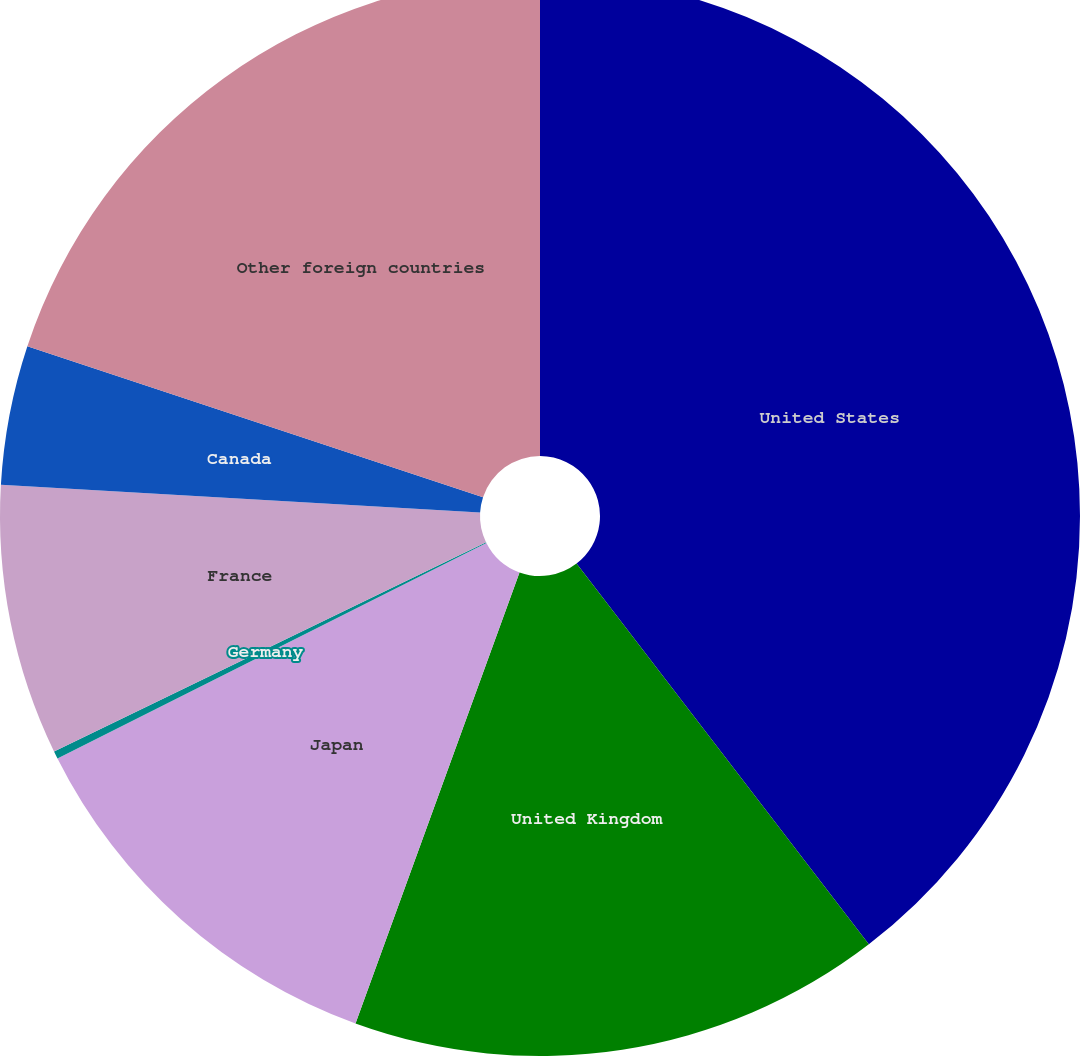Convert chart to OTSL. <chart><loc_0><loc_0><loc_500><loc_500><pie_chart><fcel>United States<fcel>United Kingdom<fcel>Japan<fcel>Germany<fcel>France<fcel>Canada<fcel>Other foreign countries<nl><fcel>39.58%<fcel>15.97%<fcel>12.04%<fcel>0.23%<fcel>8.1%<fcel>4.17%<fcel>19.91%<nl></chart> 